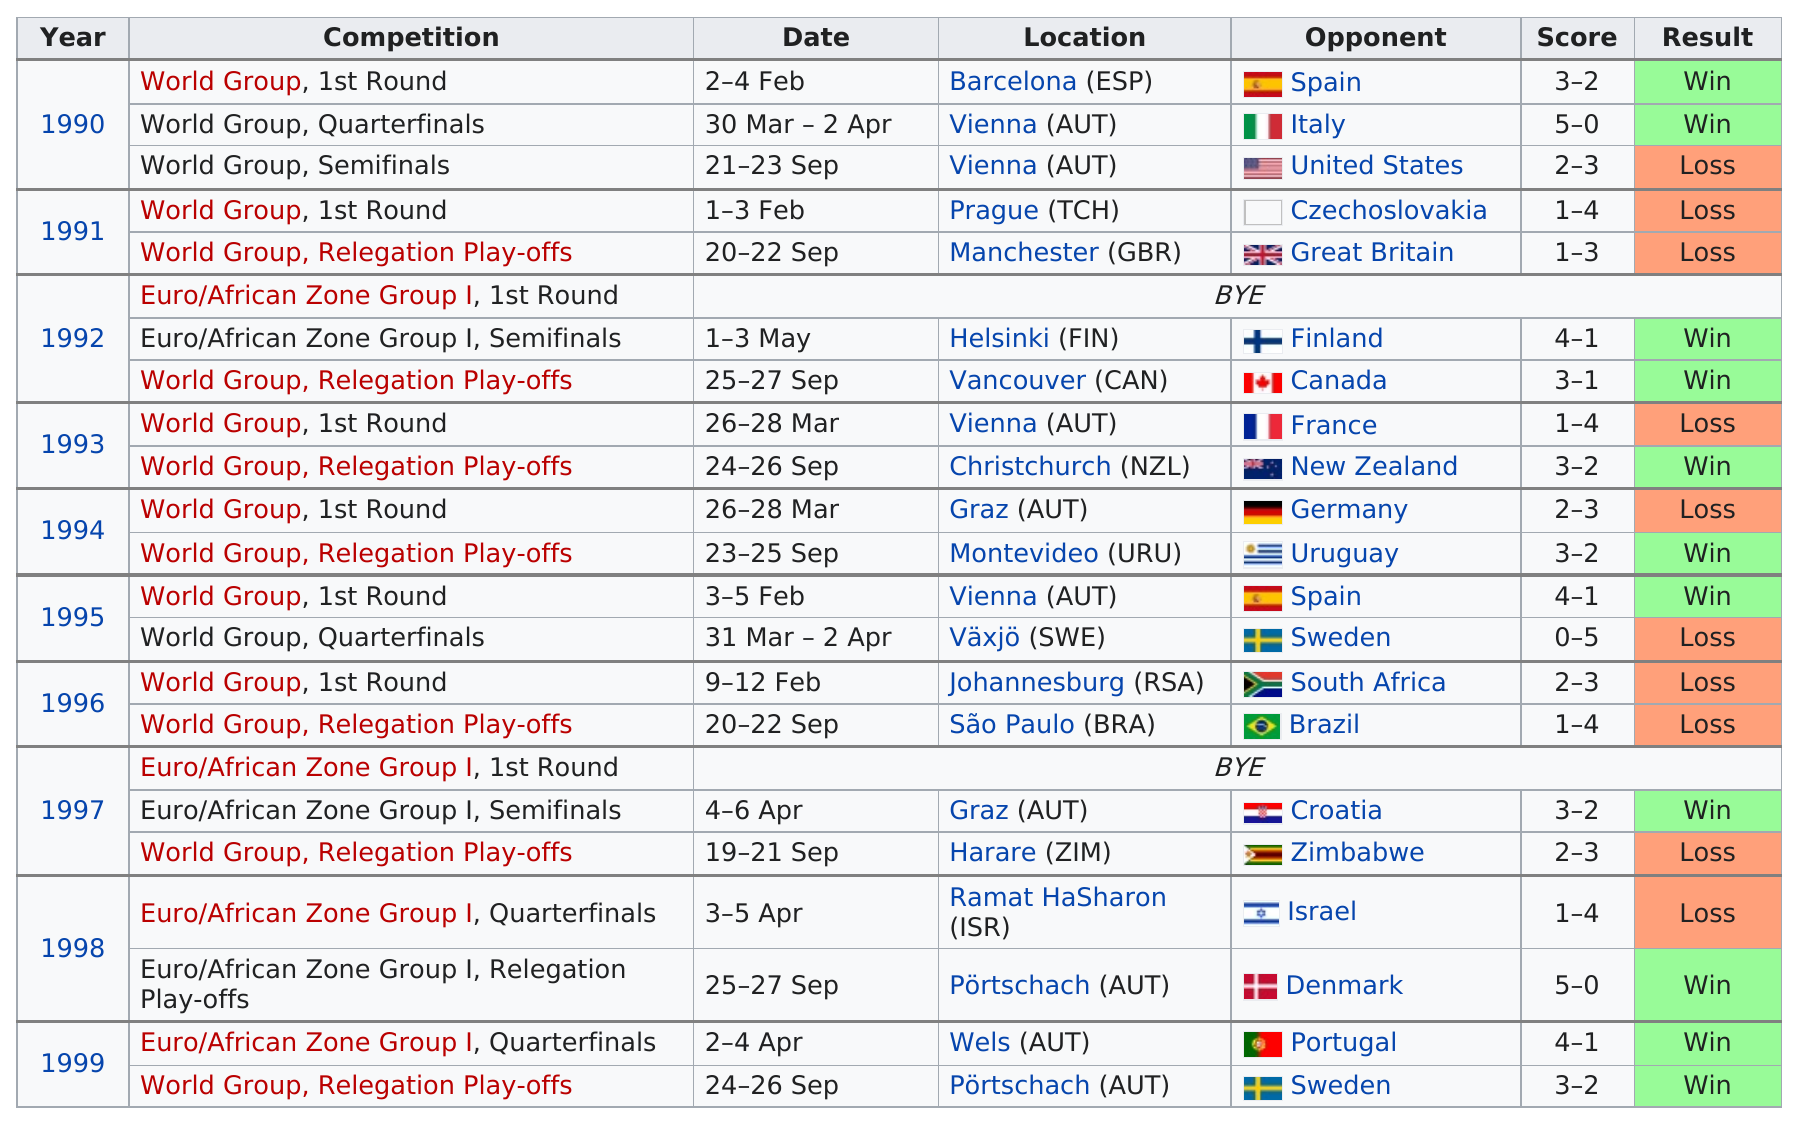Give some essential details in this illustration. The question of whether Austria won more games in 1992 or 1996 is still unknown. After defeating the Barcelona team in the World Group 1st Round in 1990, the Austria Davis Cup team went on to play against Italy. This team played two games against Spain. The last team this team played against in the 1990s was Sweden. The World Group first round was won by the group in either 1990 or 1993. It was won in 1990. 